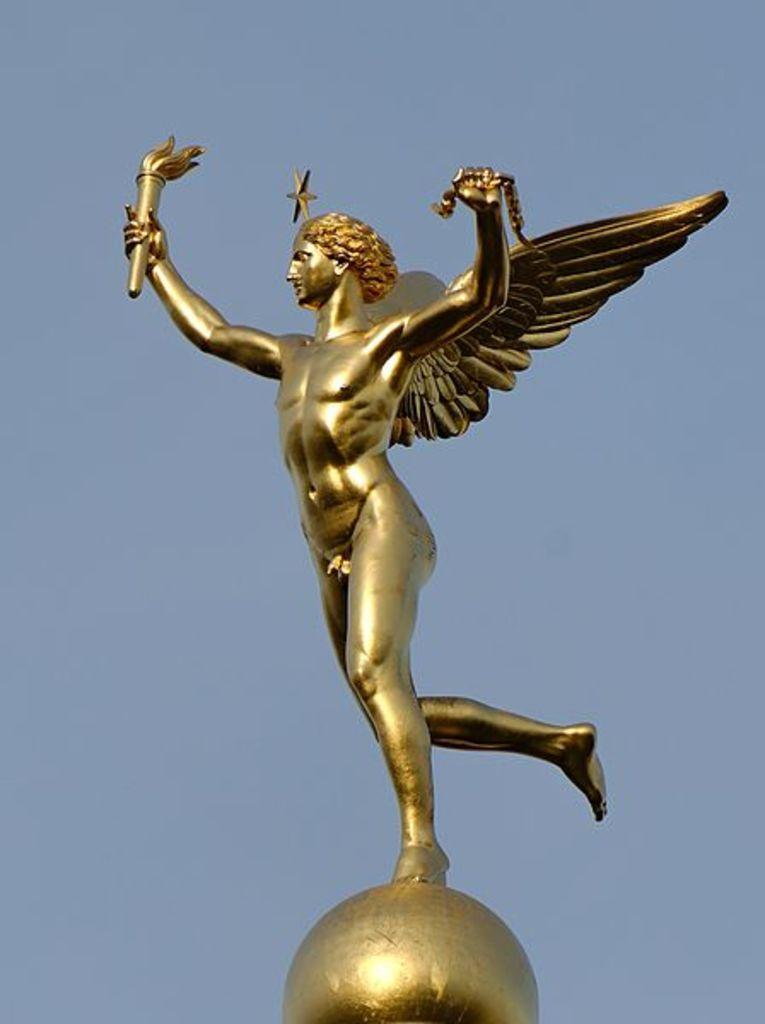In one or two sentences, can you explain what this image depicts? In this image we can see a statue and in the background, we can see the sky. 